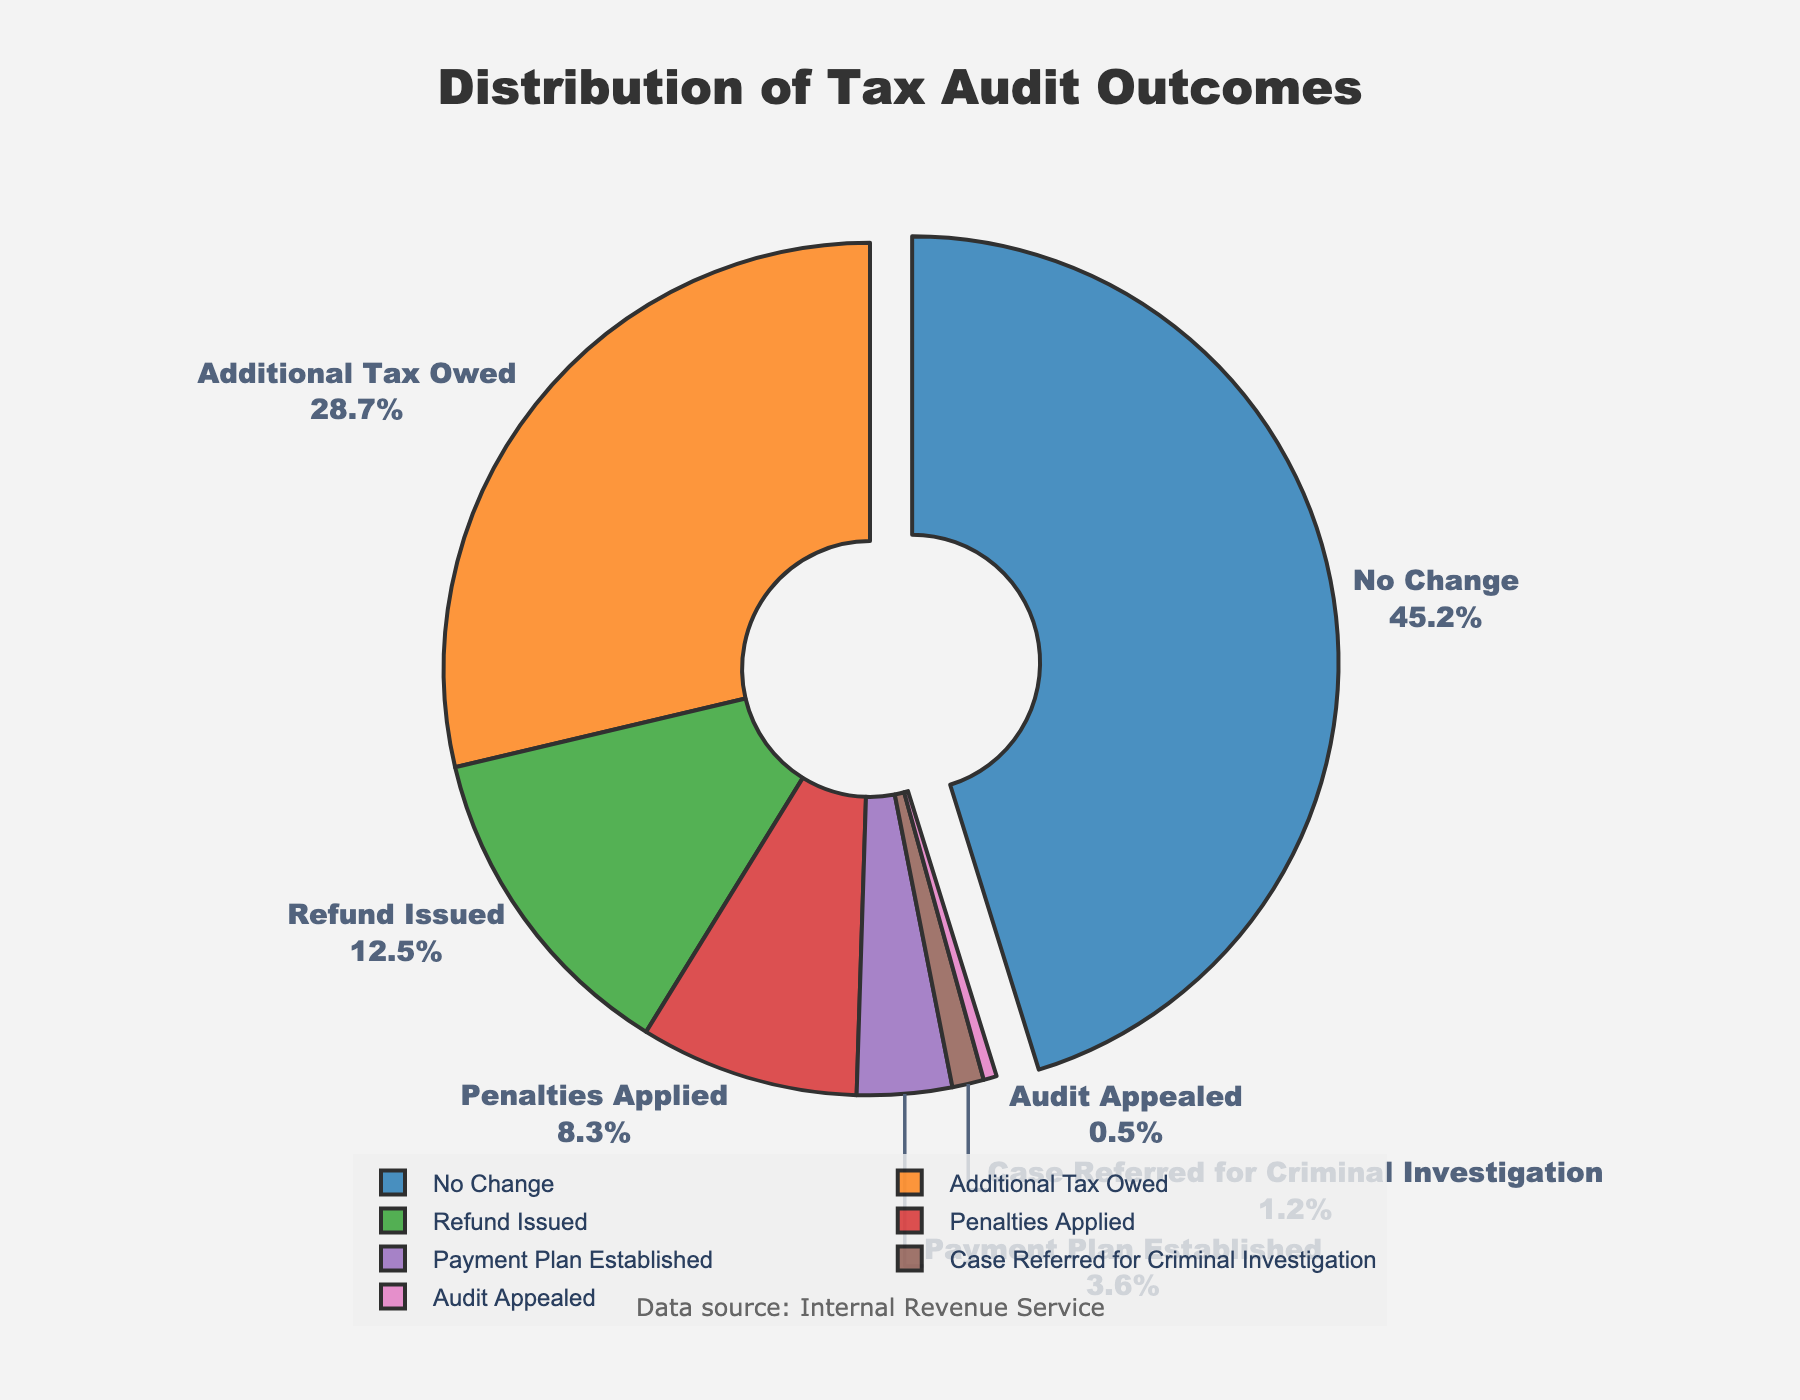Which audit outcome has the highest percentage? To find the outcome with the highest percentage, look for the largest segment in the pie chart and check its label. The outcome with the highest percentage should also be slightly pulled out from the chart.
Answer: No Change How many outcomes have a percentage greater than 10%? Examine each segment of the pie chart and identify which ones have percentages greater than 10%. Count these segments.
Answer: 3 What is the combined percentage of "Refund Issued" and "Penalties Applied"? Find the percentages for "Refund Issued" and "Penalties Applied" in the chart. Add these percentages together: 12.5% + 8.3% = 20.8%.
Answer: 20.8% Which outcome corresponds to the smallest segment in the pie chart? Look for the smallest segment visually and check its label.
Answer: Audit Appealed Compare the sum of the percentages of the "Additional Tax Owed" and "Payment Plan Established" outcomes with the percentage of the "No Change" outcome. Which is greater? First, calculate the sum of "Additional Tax Owed" and "Payment Plan Established": 28.7% + 3.6% = 32.3%. Then, compare it with the "No Change" percentage of 45.2%.
Answer: No Change What percentage of the outcomes result in a financial impact (either additional tax, penalties, or refunds)? Sum the percentages of "Additional Tax Owed," "Penalties Applied," and "Refund Issued": 28.7% + 8.3% + 12.5% = 49.5%.
Answer: 49.5% How does the percentage of "Case Referred for Criminal Investigation" compare to "Payment Plan Established"? Look at the percentages for both outcomes in the pie chart. Compare them directly: 1.2% vs 3.6%.
Answer: Payment Plan Established is greater What is the difference in percentage points between the outcomes "No Change" and "Additional Tax Owed"? Subtract the percentage of "Additional Tax Owed" from "No Change": 45.2% - 28.7% = 16.5%.
Answer: 16.5% What's the total percentage of outcomes that result in either a financial change (additional tax owed or refunds) or legal action (criminal investigation or appeal)? Sum the percentages of "Additional Tax Owed", "Refund Issued", "Case Referred for Criminal Investigation", and "Audit Appealed": 28.7% + 12.5% + 1.2% + 0.5% = 42.9%.
Answer: 42.9% What is the percentage difference between the outcomes with the highest and lowest percentages? Subtract the percentage of the lowest outcome "Audit Appealed" from the highest outcome "No Change": 45.2% - 0.5% = 44.7%.
Answer: 44.7% 